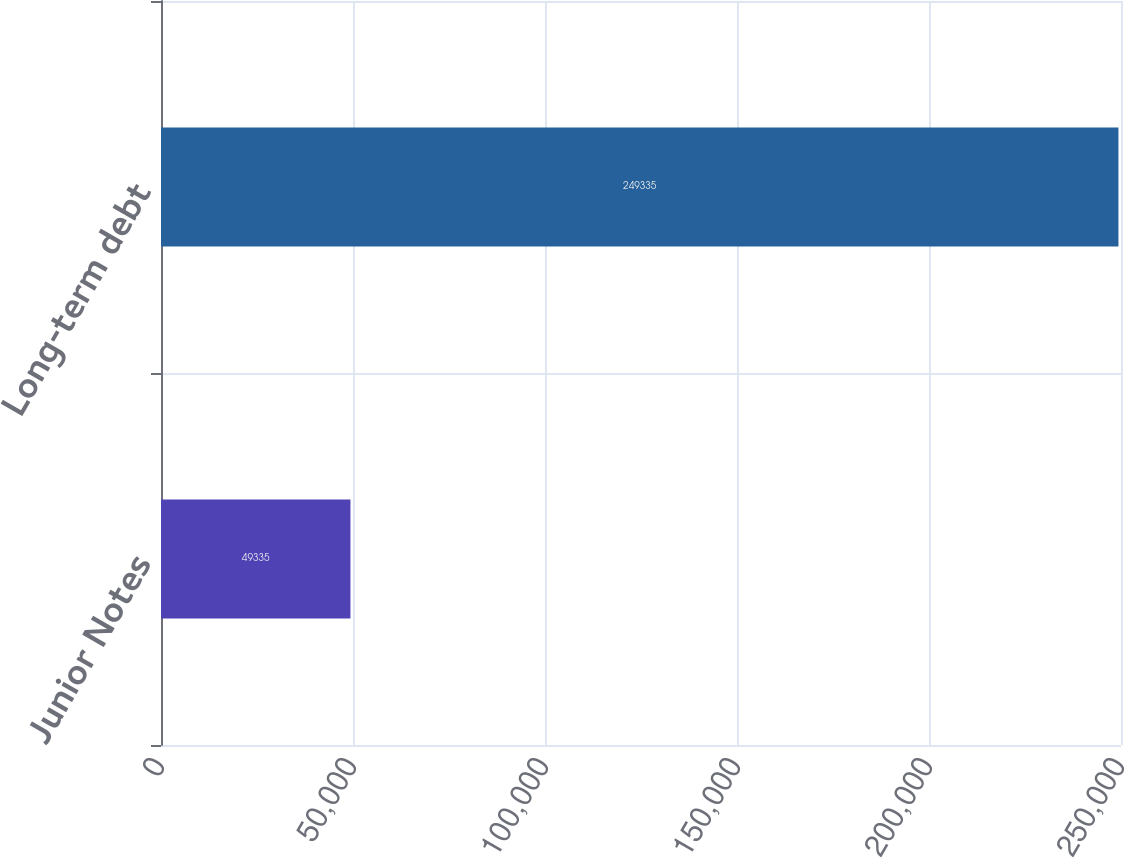<chart> <loc_0><loc_0><loc_500><loc_500><bar_chart><fcel>Junior Notes<fcel>Long-term debt<nl><fcel>49335<fcel>249335<nl></chart> 